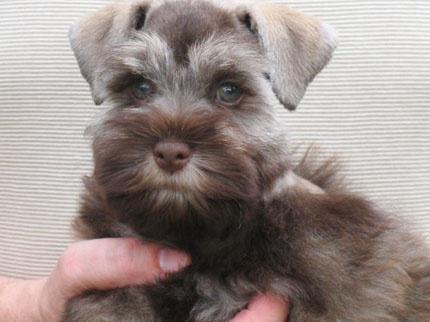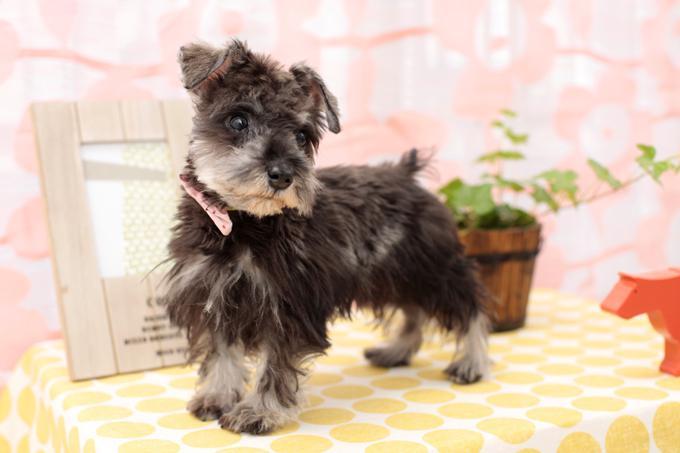The first image is the image on the left, the second image is the image on the right. Given the left and right images, does the statement "The dog in the left image is in a standing pose with body turned to the right." hold true? Answer yes or no. No. 